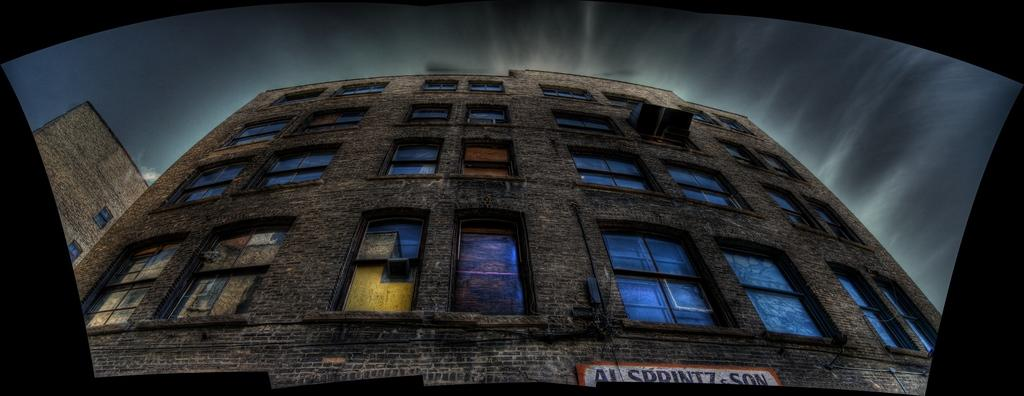What is the main structure in the picture? There is a big building in the picture. What type of windows does the building have? The building has glass windows. Is there any signage or identification for the building? Yes, there is a name board at the bottom of the building. What can be seen in the sky in the image? The sky is visible at the top of the image. What time is it according to the store's clock in the image? There is no store or clock present in the image, so it is not possible to determine the time. 